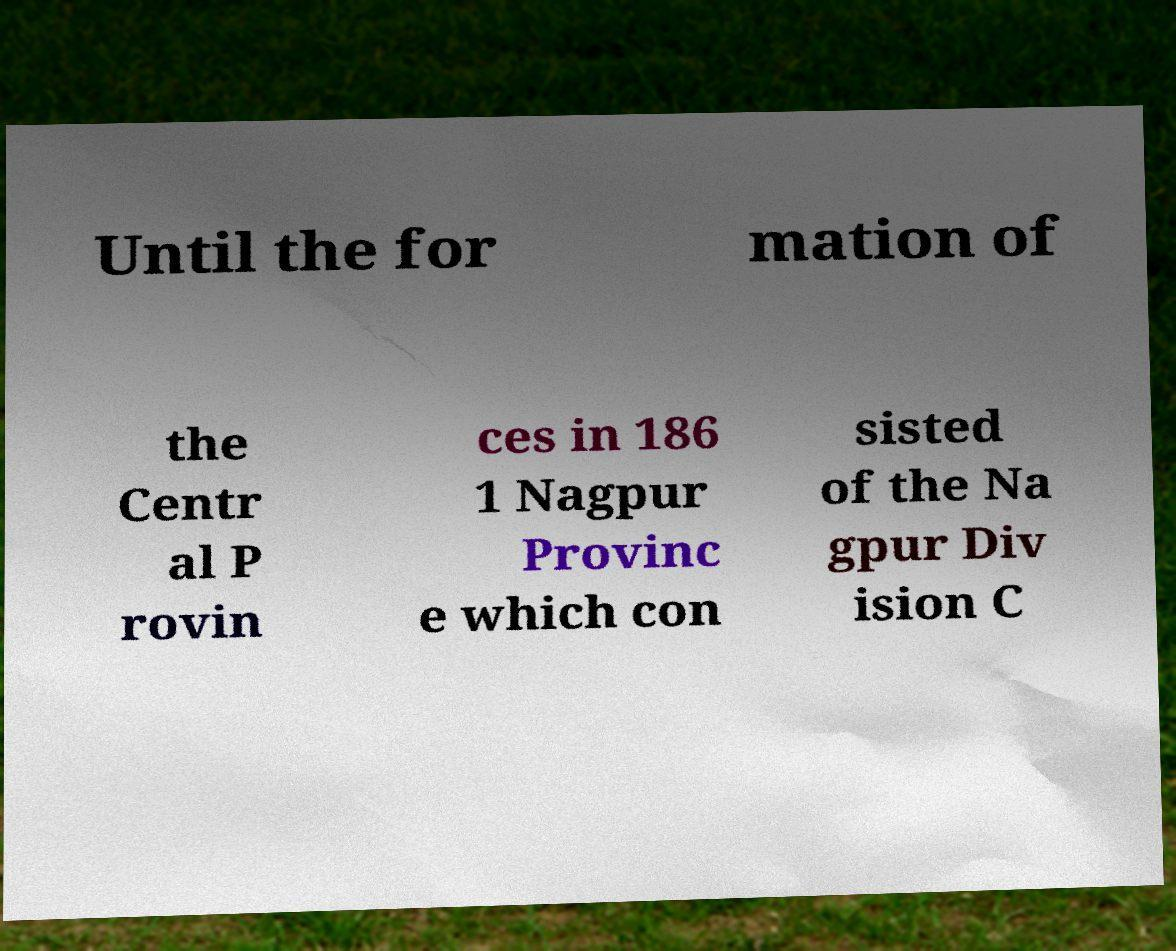For documentation purposes, I need the text within this image transcribed. Could you provide that? Until the for mation of the Centr al P rovin ces in 186 1 Nagpur Provinc e which con sisted of the Na gpur Div ision C 